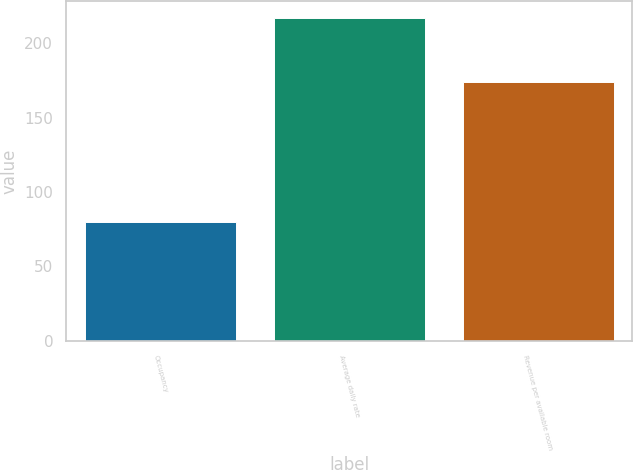Convert chart. <chart><loc_0><loc_0><loc_500><loc_500><bar_chart><fcel>Occupancy<fcel>Average daily rate<fcel>Revenue per available room<nl><fcel>80<fcel>217.23<fcel>173.8<nl></chart> 